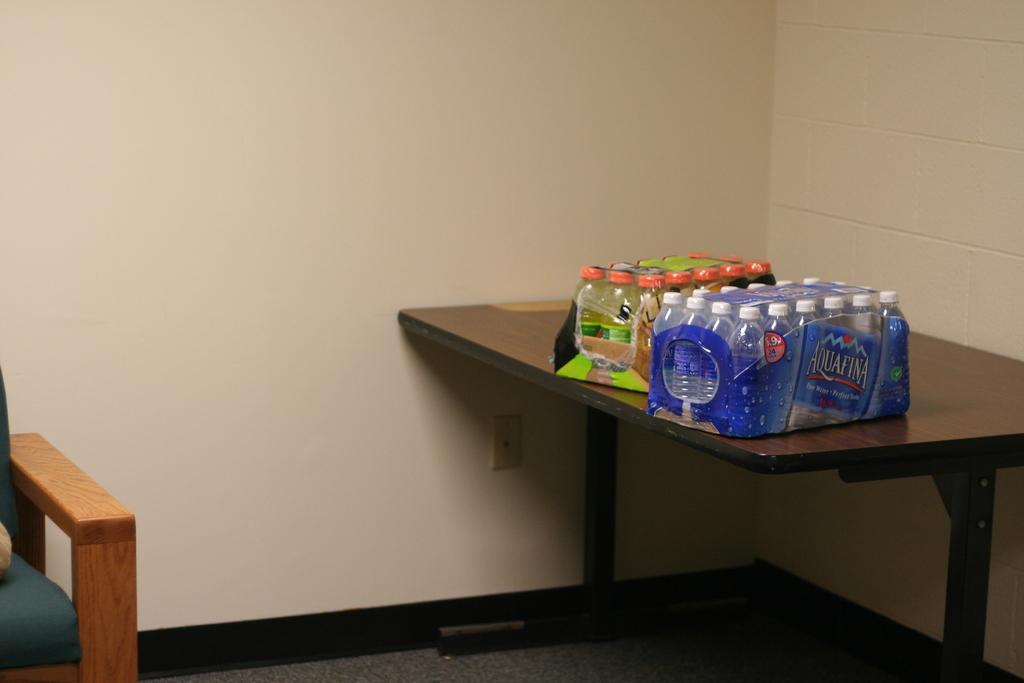Describe this image in one or two sentences. This picture is taken inside the room. In this image, on the left side, we can see a chair. On the right side, we can see a table, on the table, we can see some bottles. In the background, we can see a wall. 